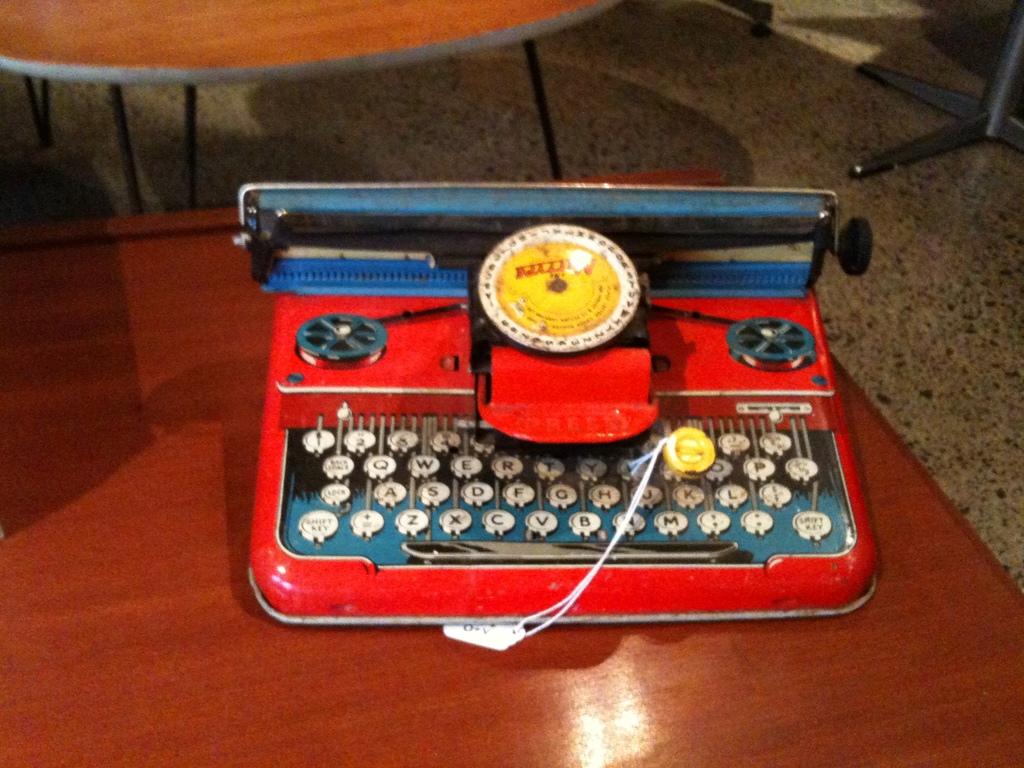What letter is between x and v?
Provide a succinct answer. C. 